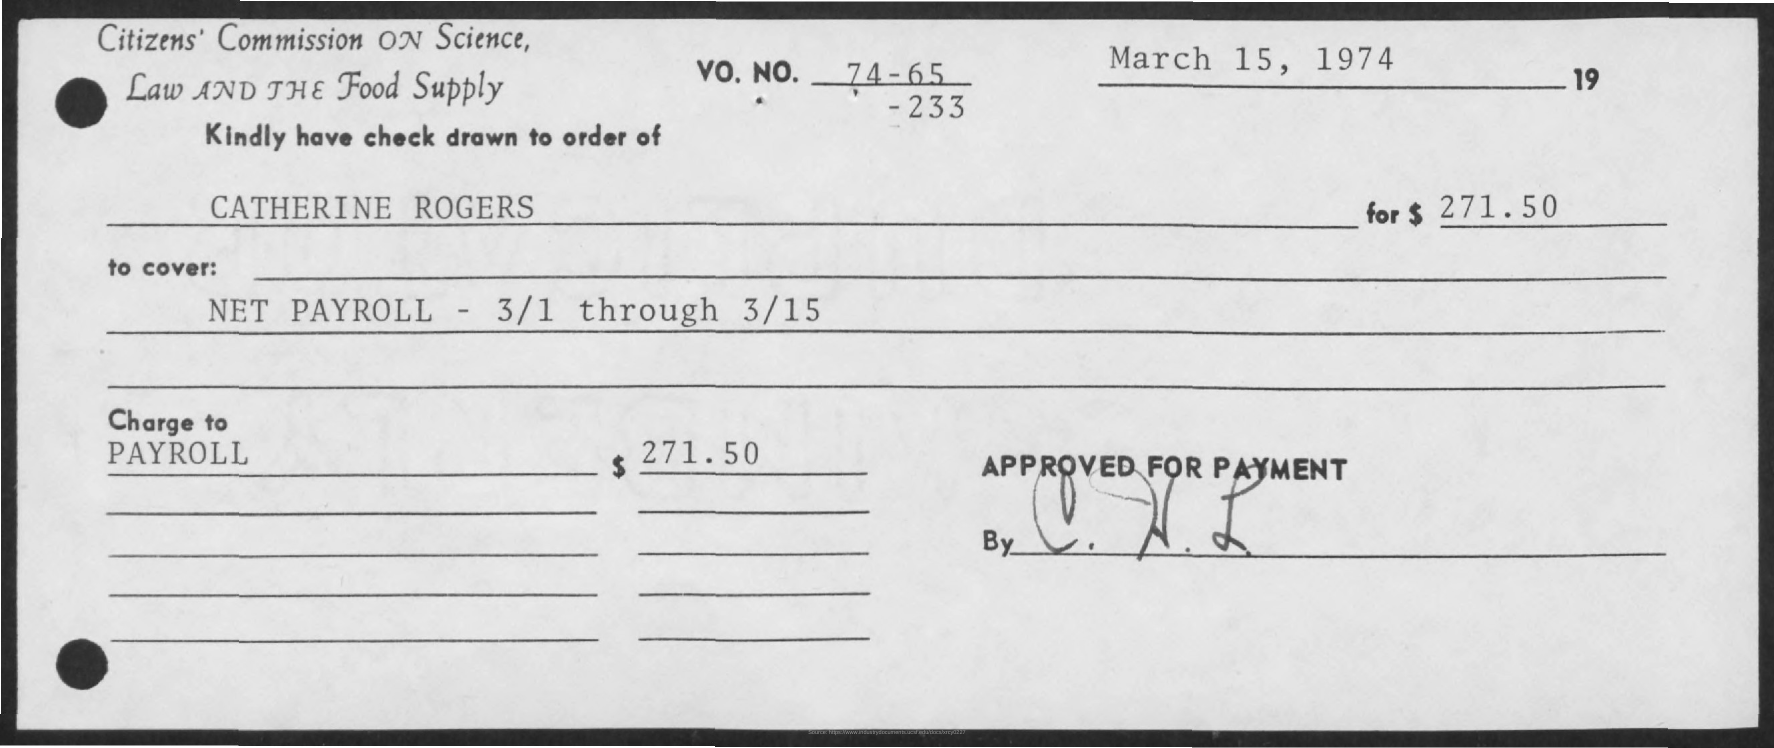Highlight a few significant elements in this photo. The check mentions an amount of $271.50. The issued date of the check is March 15, 1974. 